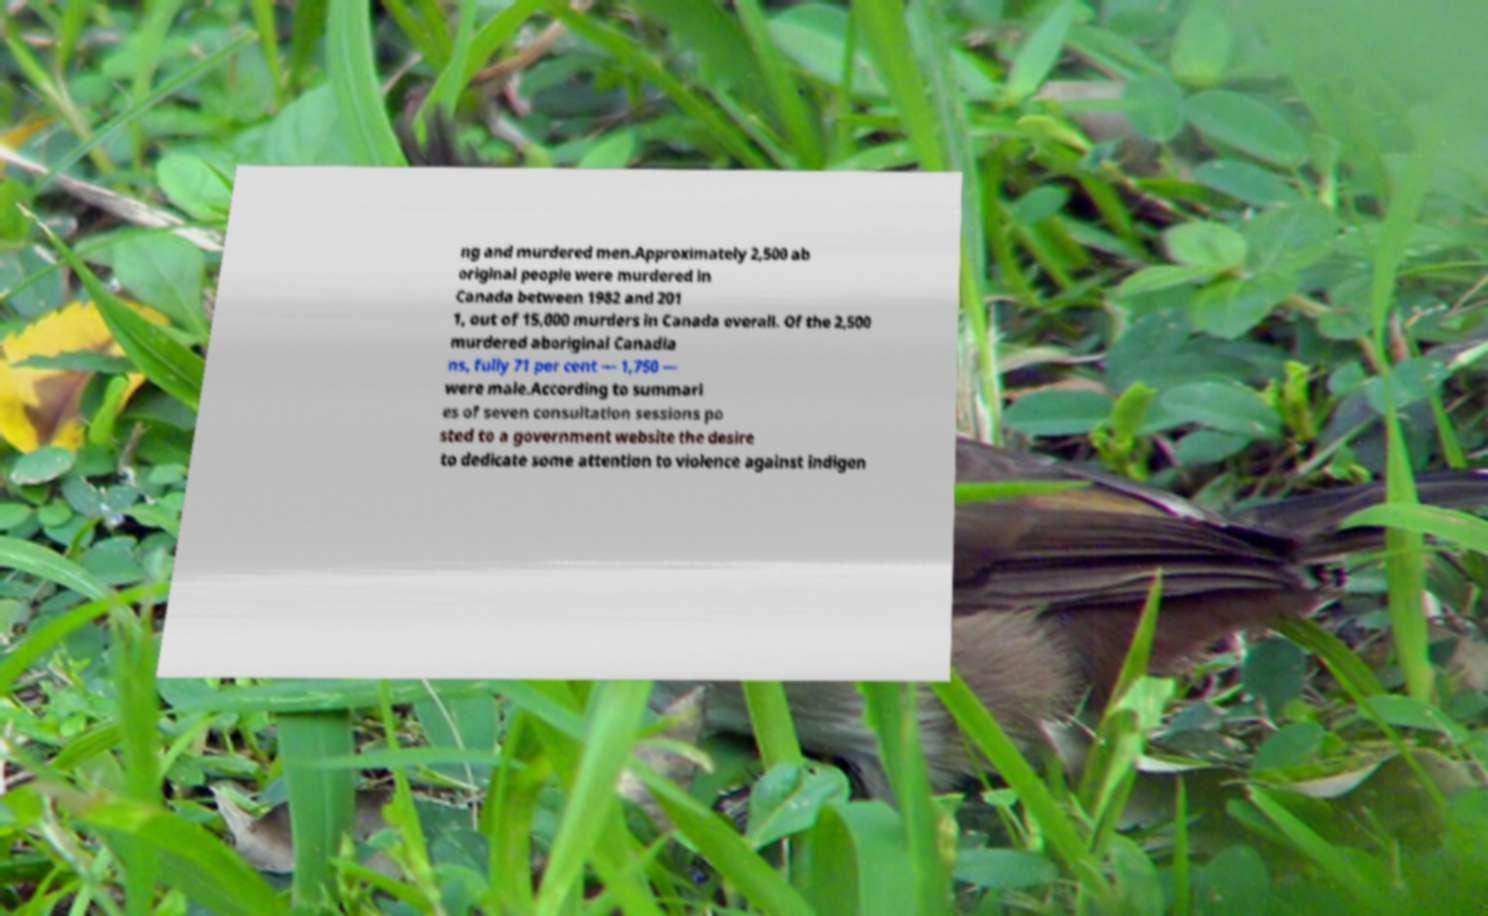Could you assist in decoding the text presented in this image and type it out clearly? ng and murdered men.Approximately 2,500 ab original people were murdered in Canada between 1982 and 201 1, out of 15,000 murders in Canada overall. Of the 2,500 murdered aboriginal Canadia ns, fully 71 per cent — 1,750 — were male.According to summari es of seven consultation sessions po sted to a government website the desire to dedicate some attention to violence against indigen 